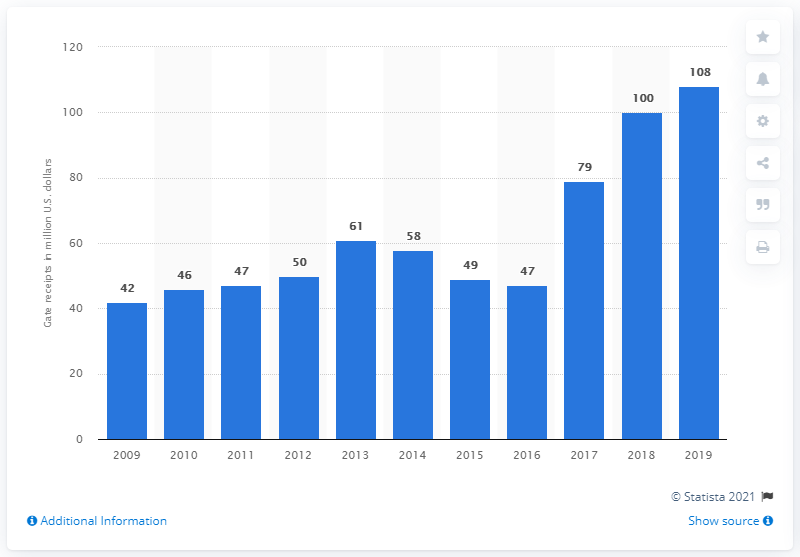Point out several critical features in this image. In 2019, the Atlanta Braves' gate receipts totaled 108.. 